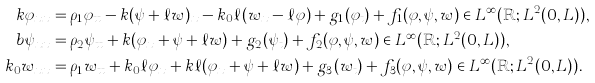Convert formula to latex. <formula><loc_0><loc_0><loc_500><loc_500>k \varphi _ { x x } & = \rho _ { 1 } \varphi _ { t t } - k ( \psi + \ell w ) _ { x } - k _ { 0 } \ell ( w _ { x } - \ell \varphi ) + g _ { 1 } ( \varphi _ { t } ) + f _ { 1 } ( \varphi , \psi , w ) \in L ^ { \infty } ( \mathbb { R } ; L ^ { 2 } ( 0 , L ) ) , \\ b \psi _ { x x } & = \rho _ { 2 } \psi _ { t t } + k ( \varphi _ { x } + \psi + \ell w ) + g _ { 2 } ( \psi _ { t } ) + f _ { 2 } ( \varphi , \psi , w ) \in L ^ { \infty } ( \mathbb { R } ; L ^ { 2 } ( 0 , L ) ) , \\ k _ { 0 } w _ { x x } & = \rho _ { 1 } w _ { t t } + k _ { 0 } \ell \varphi _ { x } + k \ell ( \varphi _ { x } + \psi + \ell w ) + g _ { 3 } ( w _ { t } ) + f _ { 3 } ( \varphi , \psi , w ) \in L ^ { \infty } ( \mathbb { R } ; L ^ { 2 } ( 0 , L ) ) .</formula> 